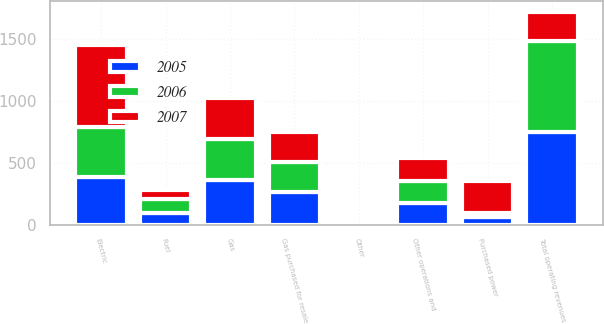<chart> <loc_0><loc_0><loc_500><loc_500><stacked_bar_chart><ecel><fcel>Electric<fcel>Gas<fcel>Other<fcel>Total operating revenues<fcel>Fuel<fcel>Purchased power<fcel>Gas purchased for resale<fcel>Other operations and<nl><fcel>2007<fcel>660<fcel>329<fcel>1<fcel>237<fcel>77<fcel>259<fcel>237<fcel>181<nl><fcel>2006<fcel>399<fcel>333<fcel>1<fcel>733<fcel>109<fcel>34<fcel>246<fcel>179<nl><fcel>2005<fcel>387<fcel>359<fcel>1<fcel>747<fcel>95<fcel>63<fcel>262<fcel>174<nl></chart> 